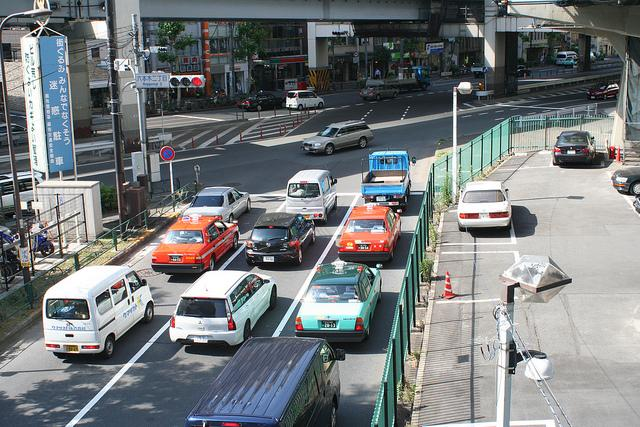What make is the white vehicle to the left of the green white cab? Please explain your reasoning. mitsubishi. There is a mitsubishi minivan next to the green cab. 